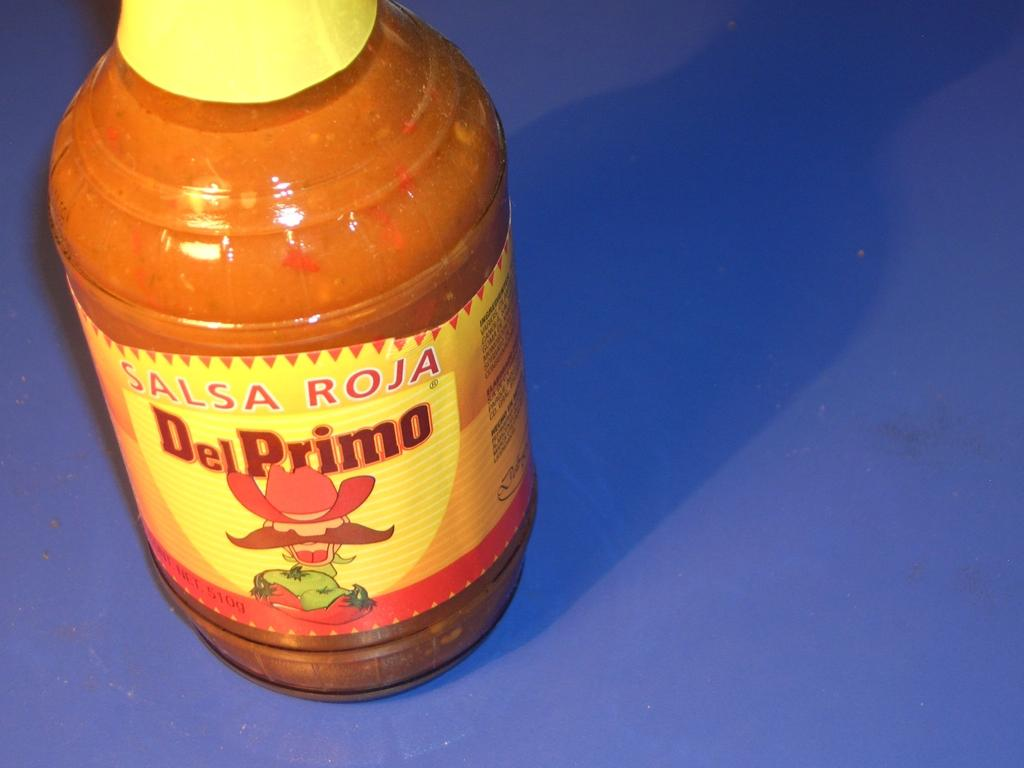<image>
Relay a brief, clear account of the picture shown. a bottle of Salsa Roja Del Primo hot sauce 